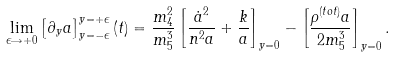<formula> <loc_0><loc_0><loc_500><loc_500>\lim _ { \epsilon \rightarrow + 0 } \left [ \partial _ { y } a \right ] _ { y = - \epsilon } ^ { y = + \epsilon } ( t ) = \frac { m _ { 4 } ^ { 2 } } { m _ { 5 } ^ { 3 } } \left [ \frac { \dot { a } ^ { 2 } } { n ^ { 2 } a } + \frac { k } { a } \right ] _ { y = 0 } - \left [ \frac { \rho ^ { ( t o t ) } a } { 2 m _ { 5 } ^ { 3 } } \right ] _ { y = 0 } .</formula> 